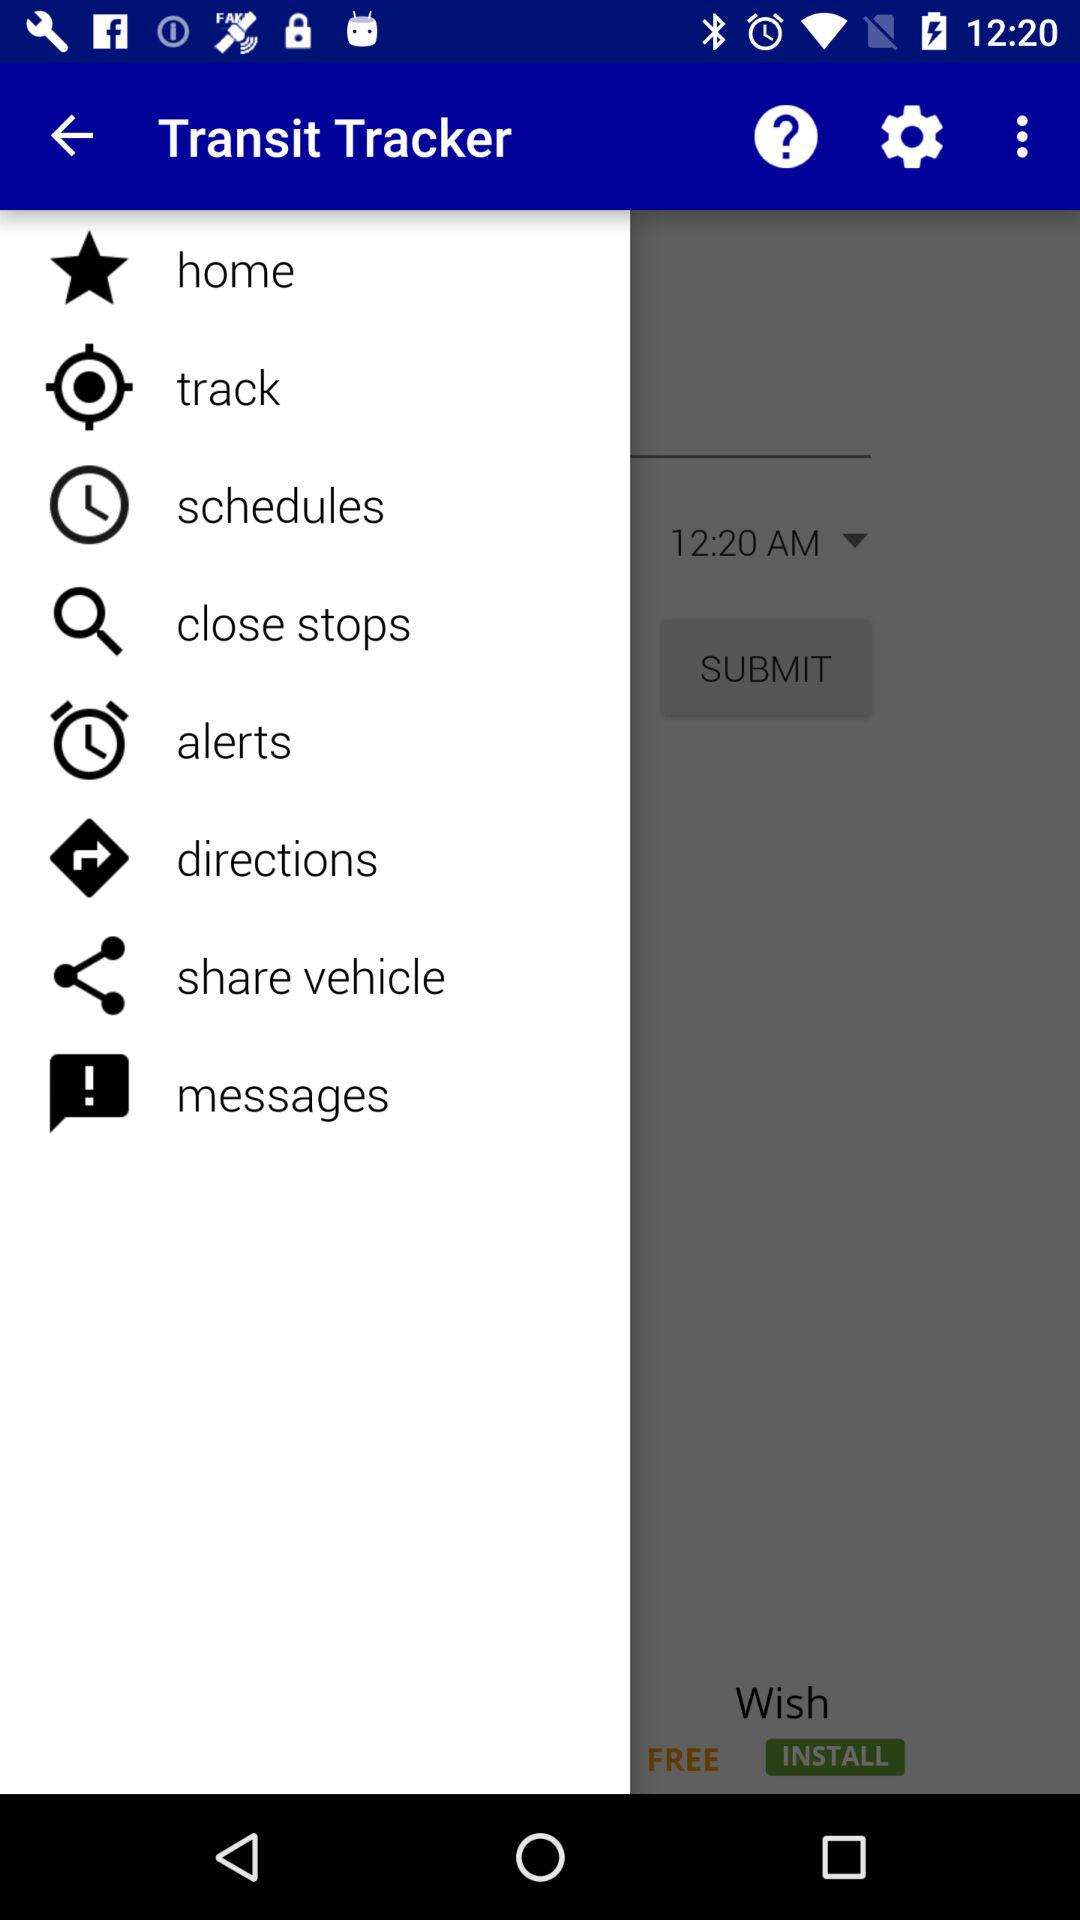How many unread messages are there?
When the provided information is insufficient, respond with <no answer>. <no answer> 